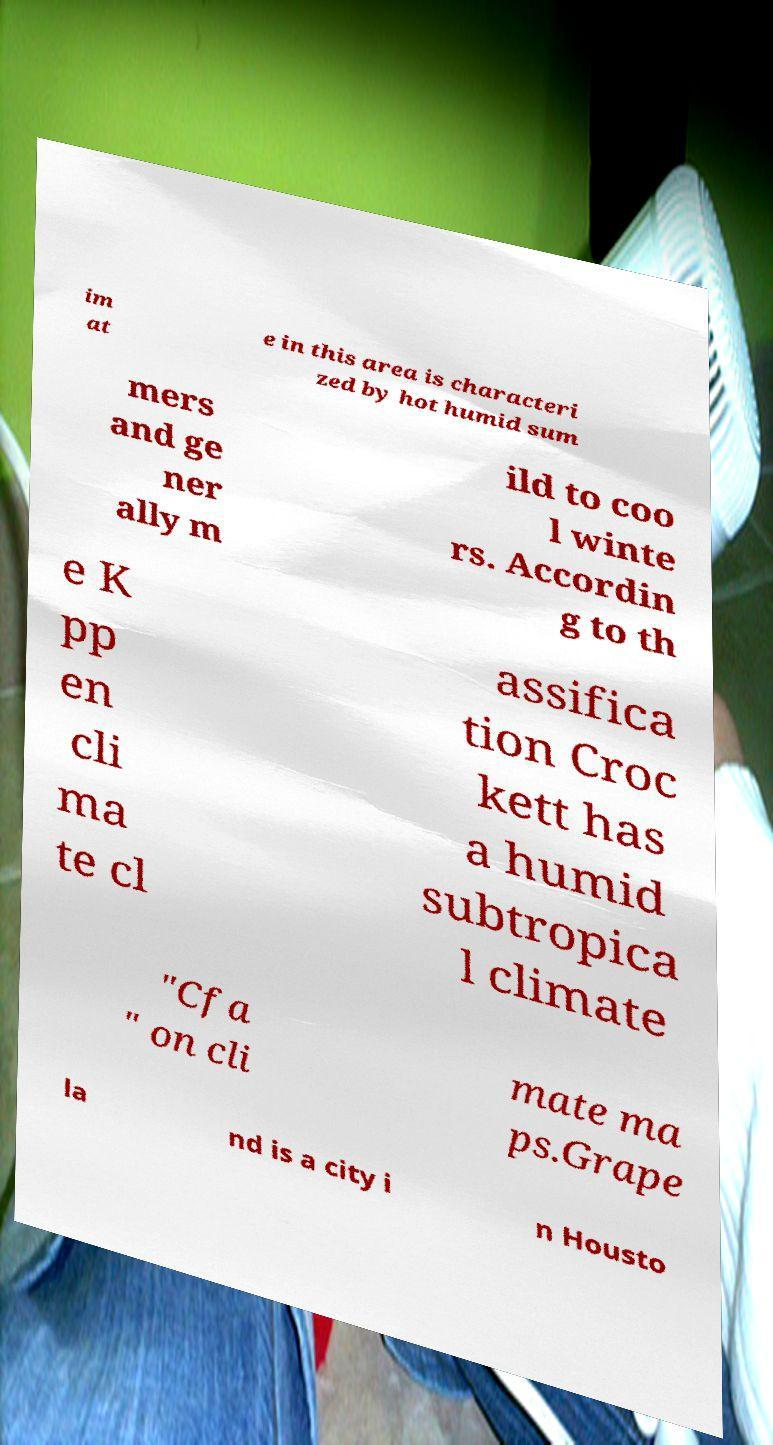Could you extract and type out the text from this image? im at e in this area is characteri zed by hot humid sum mers and ge ner ally m ild to coo l winte rs. Accordin g to th e K pp en cli ma te cl assifica tion Croc kett has a humid subtropica l climate "Cfa " on cli mate ma ps.Grape la nd is a city i n Housto 